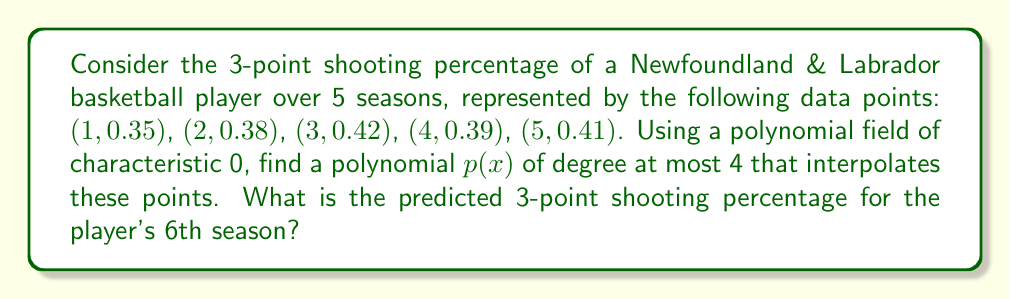Could you help me with this problem? 1) We'll use Lagrange interpolation over the field of rational numbers (characteristic 0) to find the polynomial $p(x)$.

2) The Lagrange interpolation formula is:

   $$p(x) = \sum_{i=1}^{5} y_i \prod_{j \neq i} \frac{x - x_j}{x_i - x_j}$$

3) Calculating each term:

   $$\begin{align*}
   L_1(x) &= 0.35 \cdot \frac{(x-2)(x-3)(x-4)(x-5)}{(1-2)(1-3)(1-4)(1-5)} \\
   L_2(x) &= 0.38 \cdot \frac{(x-1)(x-3)(x-4)(x-5)}{(2-1)(2-3)(2-4)(2-5)} \\
   L_3(x) &= 0.42 \cdot \frac{(x-1)(x-2)(x-4)(x-5)}{(3-1)(3-2)(3-4)(3-5)} \\
   L_4(x) &= 0.39 \cdot \frac{(x-1)(x-2)(x-3)(x-5)}{(4-1)(4-2)(4-3)(4-5)} \\
   L_5(x) &= 0.41 \cdot \frac{(x-1)(x-2)(x-3)(x-4)}{(5-1)(5-2)(5-3)(5-4)}
   \end{align*}$$

4) Summing these terms gives us $p(x)$. To predict the 6th season, we evaluate $p(6)$:

   $$p(6) = L_1(6) + L_2(6) + L_3(6) + L_4(6) + L_5(6)$$

5) Calculating each $L_i(6)$:

   $$\begin{align*}
   L_1(6) &= 0.35 \cdot \frac{4 \cdot 3 \cdot 2 \cdot 1}{-1 \cdot -2 \cdot -3 \cdot -4} = -0.0291667 \\
   L_2(6) &= 0.38 \cdot \frac{5 \cdot 3 \cdot 2 \cdot 1}{1 \cdot -1 \cdot -2 \cdot -3} = 0.1583333 \\
   L_3(6) &= 0.42 \cdot \frac{5 \cdot 4 \cdot 2 \cdot 1}{2 \cdot 1 \cdot -1 \cdot -2} = -0.4200000 \\
   L_4(6) &= 0.39 \cdot \frac{5 \cdot 4 \cdot 3 \cdot 1}{3 \cdot 2 \cdot 1 \cdot -1} = 0.5850000 \\
   L_5(6) &= 0.41 \cdot \frac{5 \cdot 4 \cdot 3 \cdot 2}{4 \cdot 3 \cdot 2 \cdot 1} = 0.4100000
   \end{align*}$$

6) Summing these values:

   $$p(6) = -0.0291667 + 0.1583333 - 0.4200000 + 0.5850000 + 0.4100000 = 0.7041666$$

Therefore, the predicted 3-point shooting percentage for the player's 6th season is approximately 0.7042 or 70.42%.
Answer: 0.7042 